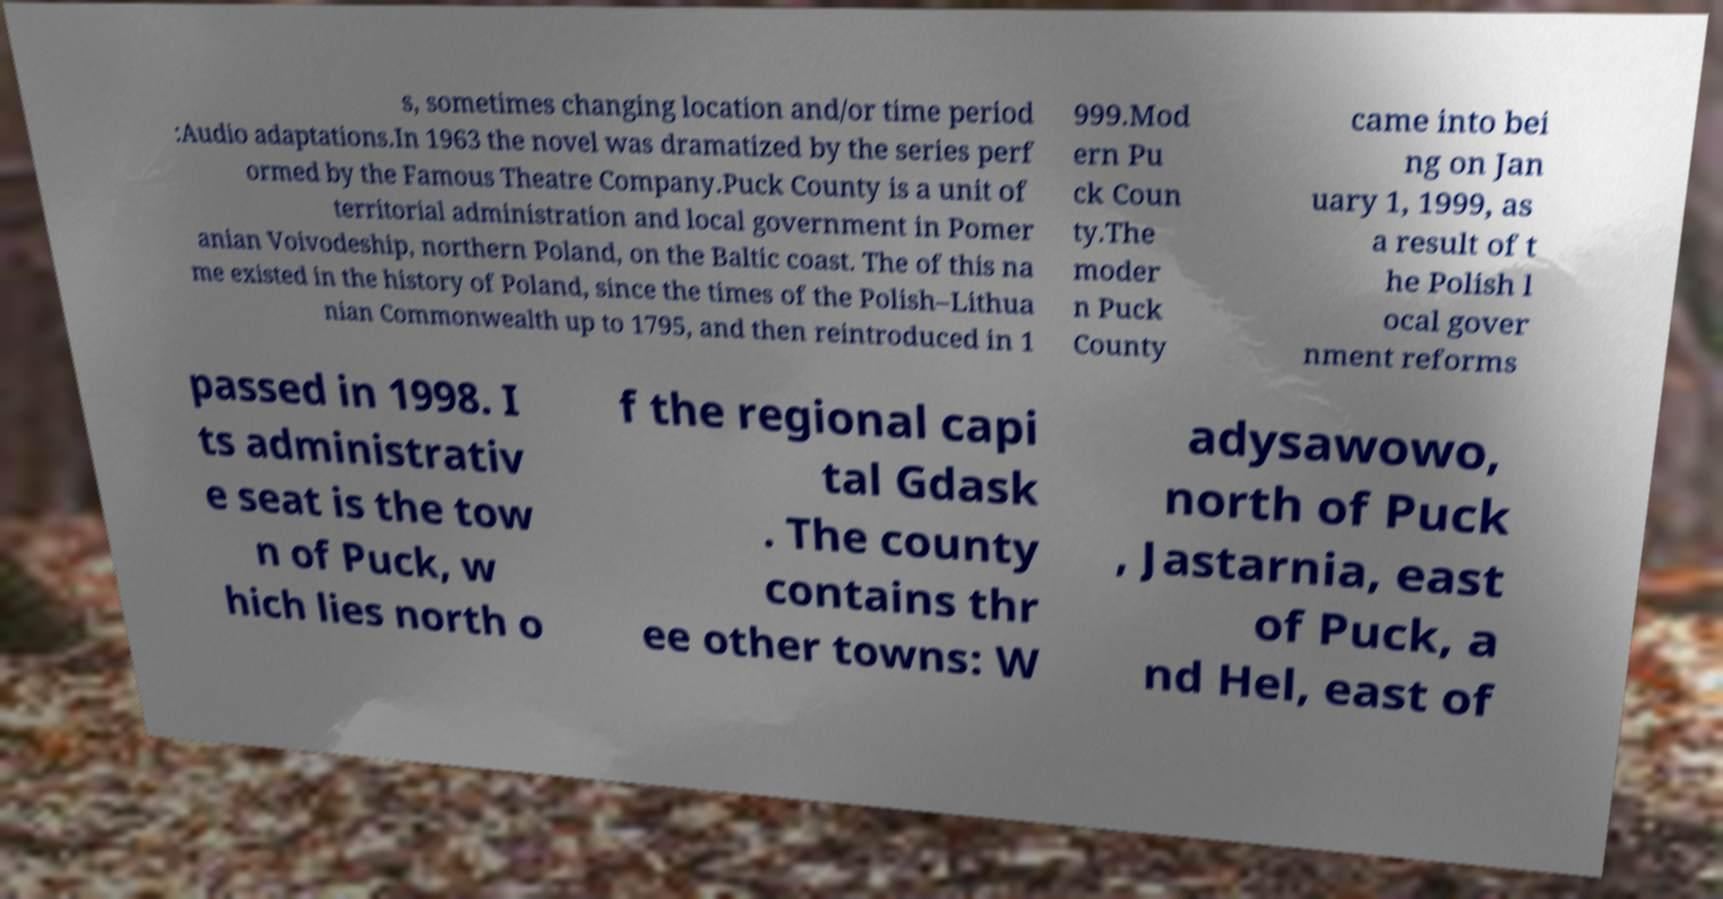Please identify and transcribe the text found in this image. s, sometimes changing location and/or time period :Audio adaptations.In 1963 the novel was dramatized by the series perf ormed by the Famous Theatre Company.Puck County is a unit of territorial administration and local government in Pomer anian Voivodeship, northern Poland, on the Baltic coast. The of this na me existed in the history of Poland, since the times of the Polish–Lithua nian Commonwealth up to 1795, and then reintroduced in 1 999.Mod ern Pu ck Coun ty.The moder n Puck County came into bei ng on Jan uary 1, 1999, as a result of t he Polish l ocal gover nment reforms passed in 1998. I ts administrativ e seat is the tow n of Puck, w hich lies north o f the regional capi tal Gdask . The county contains thr ee other towns: W adysawowo, north of Puck , Jastarnia, east of Puck, a nd Hel, east of 